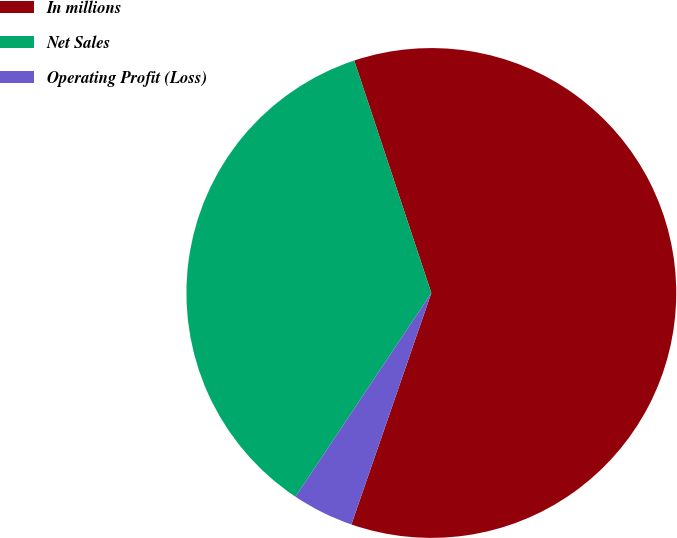Convert chart to OTSL. <chart><loc_0><loc_0><loc_500><loc_500><pie_chart><fcel>In millions<fcel>Net Sales<fcel>Operating Profit (Loss)<nl><fcel>60.39%<fcel>35.54%<fcel>4.07%<nl></chart> 